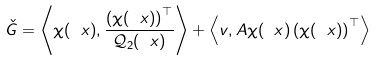Convert formula to latex. <formula><loc_0><loc_0><loc_500><loc_500>\check { G } = \left \langle \chi ( \ x ) , \frac { \left ( \chi ( \ x ) \right ) ^ { \top } } { \mathcal { Q } _ { 2 } ( \ x ) } \right \rangle + \left \langle v , A \chi ( \ x ) \left ( \chi ( \ x ) \right ) ^ { \top } \right \rangle</formula> 